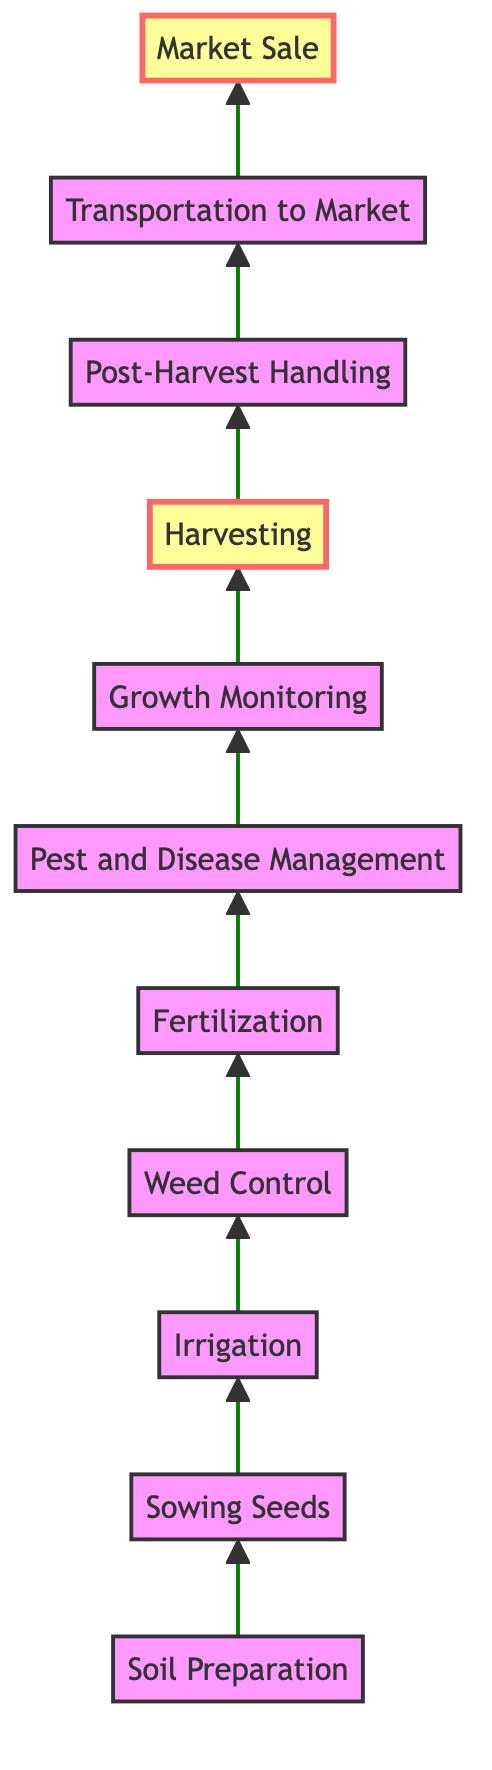What is the last step in the crop lifecycle? The diagram shows a flow from "Soil Preparation" at the bottom to "Market Sale" at the top. "Market Sale" is the endpoint and thus the last step in the lifecycle.
Answer: Market Sale How many steps are there in total? Counting the individual nodes in the diagram, there are eleven distinct steps involved from preparation to market sale.
Answer: Eleven Which step involves collecting mature crops? The diagram indicates that the step titled "Harvesting" directly involves collecting the mature crops.
Answer: Harvesting What comes after "Post-Harvest Handling"? Based on the flow direction from the diagram, "Transportation to Market" is the next step following "Post-Harvest Handling."
Answer: Transportation to Market What is the fourth step in the crop lifecycle? Referring to the sequence of steps presented in the diagram, the fourth step is "Weed Control."
Answer: Weed Control How many steps occur between "Sowing Seeds" and "Harvesting"? The sequence shows there are four steps between "Sowing Seeds" and "Harvesting": "Irrigation," "Weed Control," "Fertilization," and "Pest and Disease Management."
Answer: Four Which two steps are highlighted in the diagram? The diagram specifically highlights the steps "Harvesting" and "Market Sale," emphasizing their importance.
Answer: Harvesting, Market Sale What is the purpose of the "Fertilization" step? The diagram describes the purpose of "Fertilization" as applying fertilizers to provide essential nutrients for crop development.
Answer: Providing nutrients What does "Growth Monitoring" involve? According to the diagram, "Growth Monitoring" involves regularly inspecting crops to assess the growth progress and address any issues.
Answer: Inspecting crops Which step precedes "Weed Control"? By following the flow from bottom to top in the diagram, the step that comes before "Weed Control" is "Irrigation."
Answer: Irrigation 